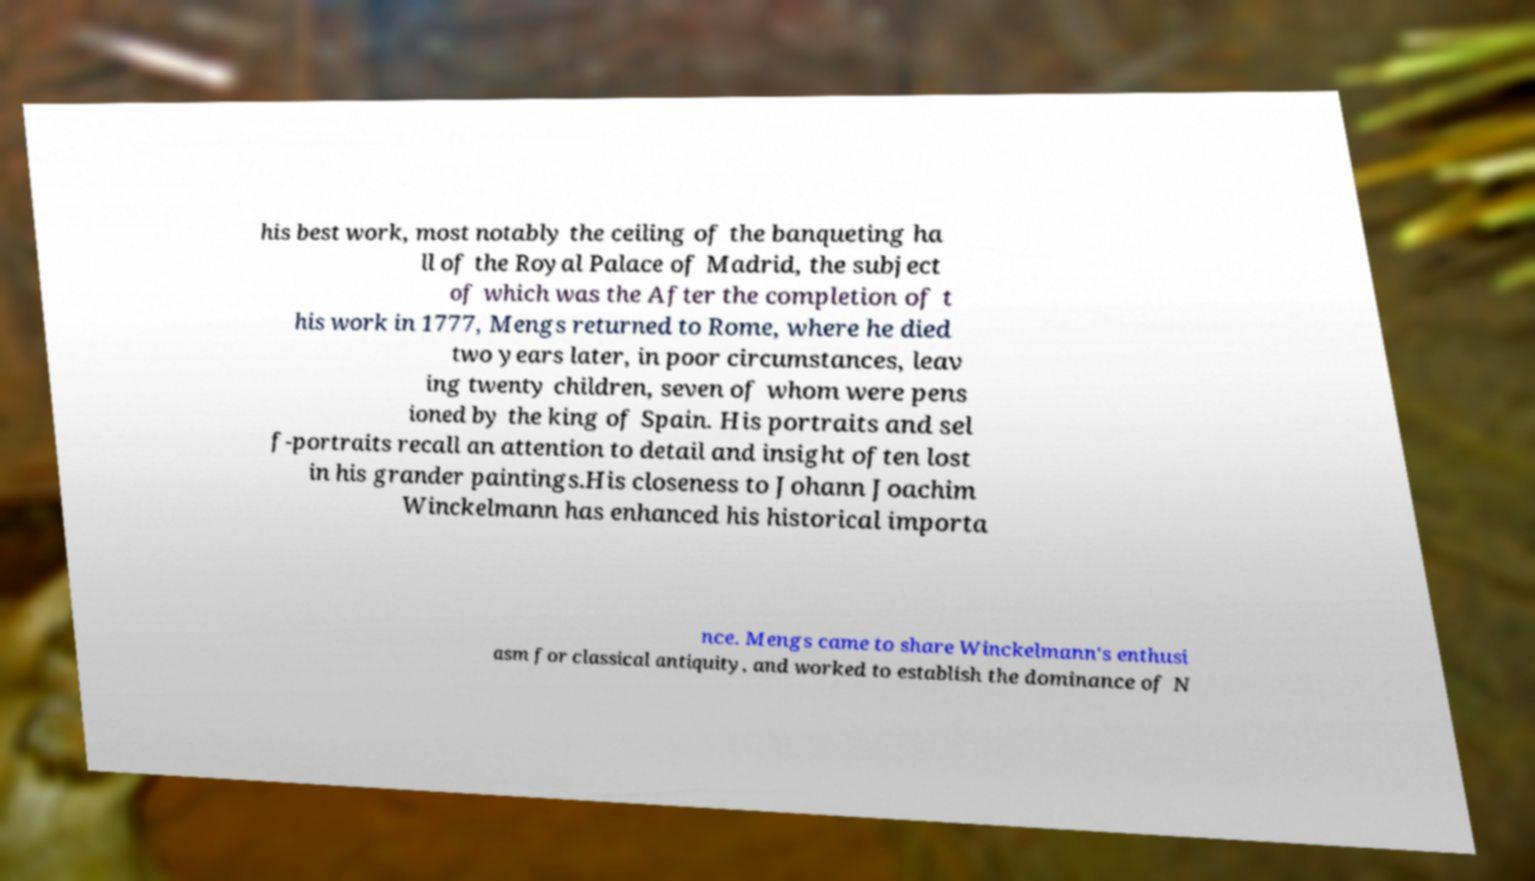What messages or text are displayed in this image? I need them in a readable, typed format. his best work, most notably the ceiling of the banqueting ha ll of the Royal Palace of Madrid, the subject of which was the After the completion of t his work in 1777, Mengs returned to Rome, where he died two years later, in poor circumstances, leav ing twenty children, seven of whom were pens ioned by the king of Spain. His portraits and sel f-portraits recall an attention to detail and insight often lost in his grander paintings.His closeness to Johann Joachim Winckelmann has enhanced his historical importa nce. Mengs came to share Winckelmann's enthusi asm for classical antiquity, and worked to establish the dominance of N 